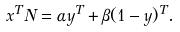Convert formula to latex. <formula><loc_0><loc_0><loc_500><loc_500>{ x } ^ { T } N = \alpha { y } ^ { T } + \beta ( { 1 } - { y } ) ^ { T } .</formula> 